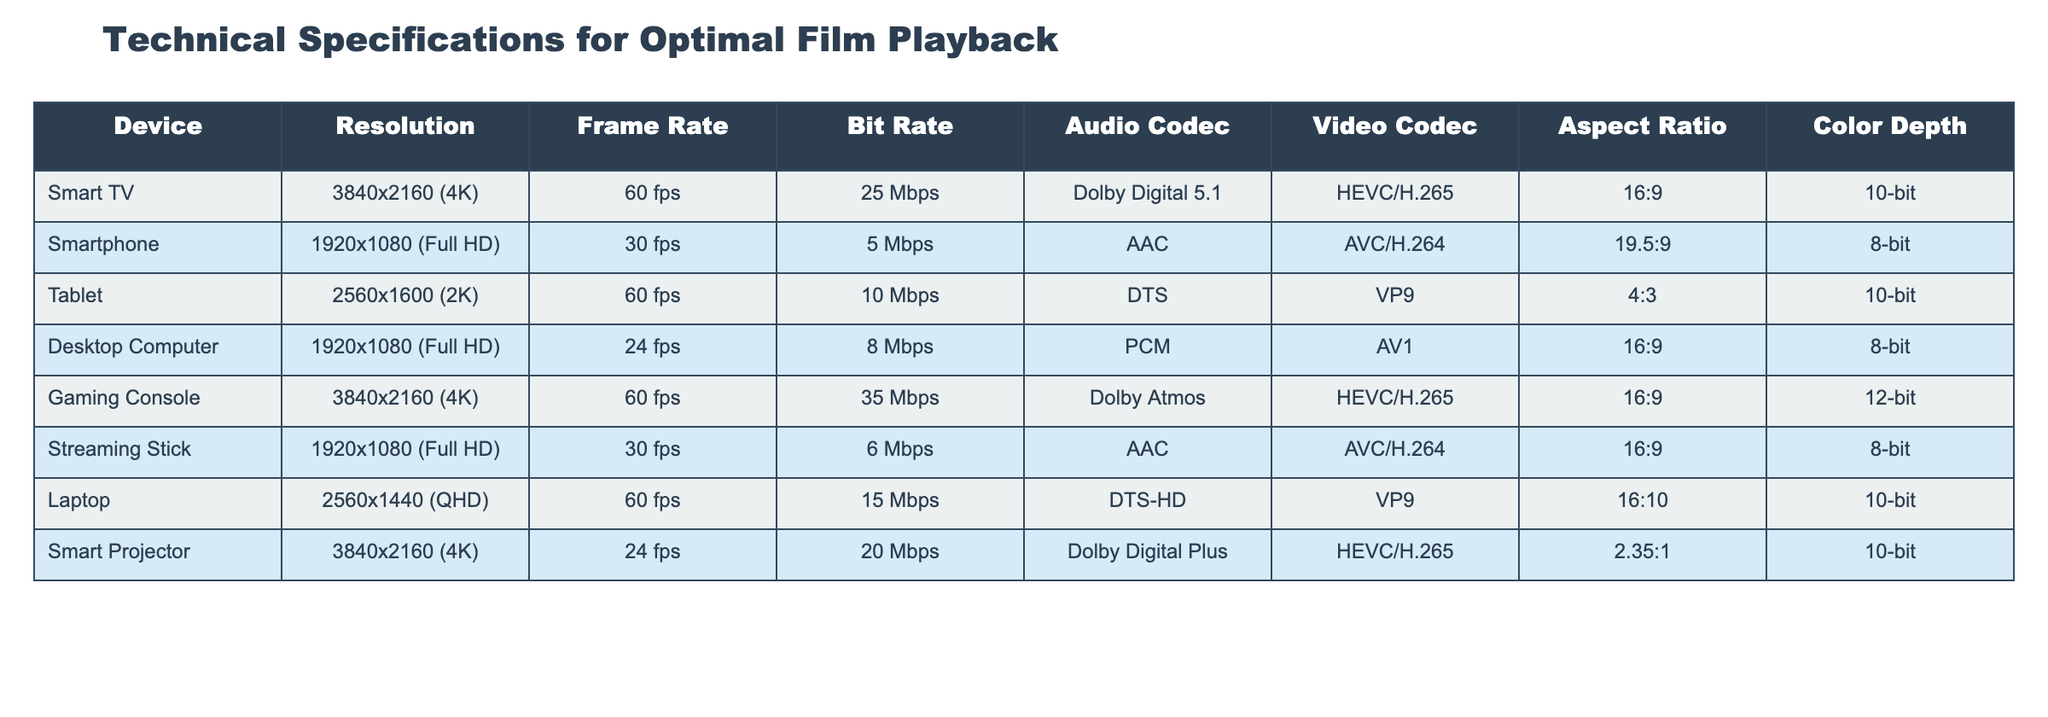What is the resolution of a Smart TV? The table shows that the resolution for a Smart TV is 3840x2160 (4K).
Answer: 3840x2160 (4K) Which device has the highest bit rate? The table lists the Gaming Console with a bit rate of 35 Mbps, which is higher than any other device.
Answer: Gaming Console Is the audio codec for Smartphones AAC? By examining the table, it can be seen that the audio codec for Smartphones is indeed AAC.
Answer: Yes What is the average frame rate of all devices listed? The frame rates are 60 fps (Smart TV, Tablet, Gaming Console, Laptop), 30 fps (Smartphone, Streaming Stick), and 24 fps (Desktop Computer, Smart Projector). The total is 60 + 30 + 60 + 24 + 60 + 30 + 24 = 288 and there are 8 devices, so the average frame rate is 288/8 = 36 fps.
Answer: 36 fps Which device has the lowest color depth? The table indicates that the Desktop Computer and Streaming Stick both have a color depth of 8-bit, which is the lowest among all devices.
Answer: Desktop Computer and Streaming Stick How many devices support 4K resolution? From the table, the Smart TV, Gaming Console, and Smart Projector are the devices supporting 4K resolution, which totals to 3 devices.
Answer: 3 devices What is the difference in bit rate between the Gaming Console and the Smart Projector? The Gaming Console has a bit rate of 35 Mbps, while the Smart Projector has a bit rate of 20 Mbps. The difference is 35 - 20 = 15 Mbps.
Answer: 15 Mbps Do all devices listed have a 16:9 aspect ratio? Checking the table reveals that not all devices have a 16:9 aspect ratio; the Tablet has a 4:3 aspect ratio and the Smart Projector has a 2.35:1 aspect ratio.
Answer: No Which device has the highest resolution and what is it? The Smart TV and Gaming Console both have a resolution of 3840x2160 (4K), which is the highest resolution in the table.
Answer: Smart TV and Gaming Console (3840x2160) What is the total bit rate for all devices combined? Summing the bit rates from the table gives: 25 + 5 + 10 + 8 + 35 + 6 + 15 + 20 = 124 Mbps.
Answer: 124 Mbps 